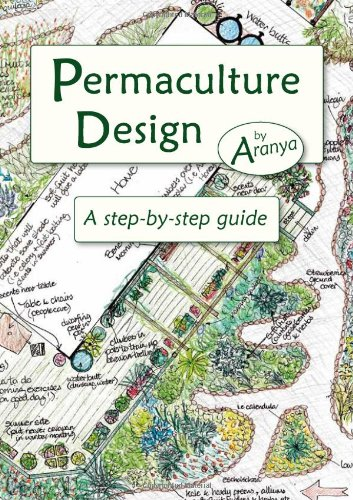Who wrote this book? This enlightening book on ecological design, 'Permaculture Design: A Step-by-Step Guide,' was authored by Aranya. 